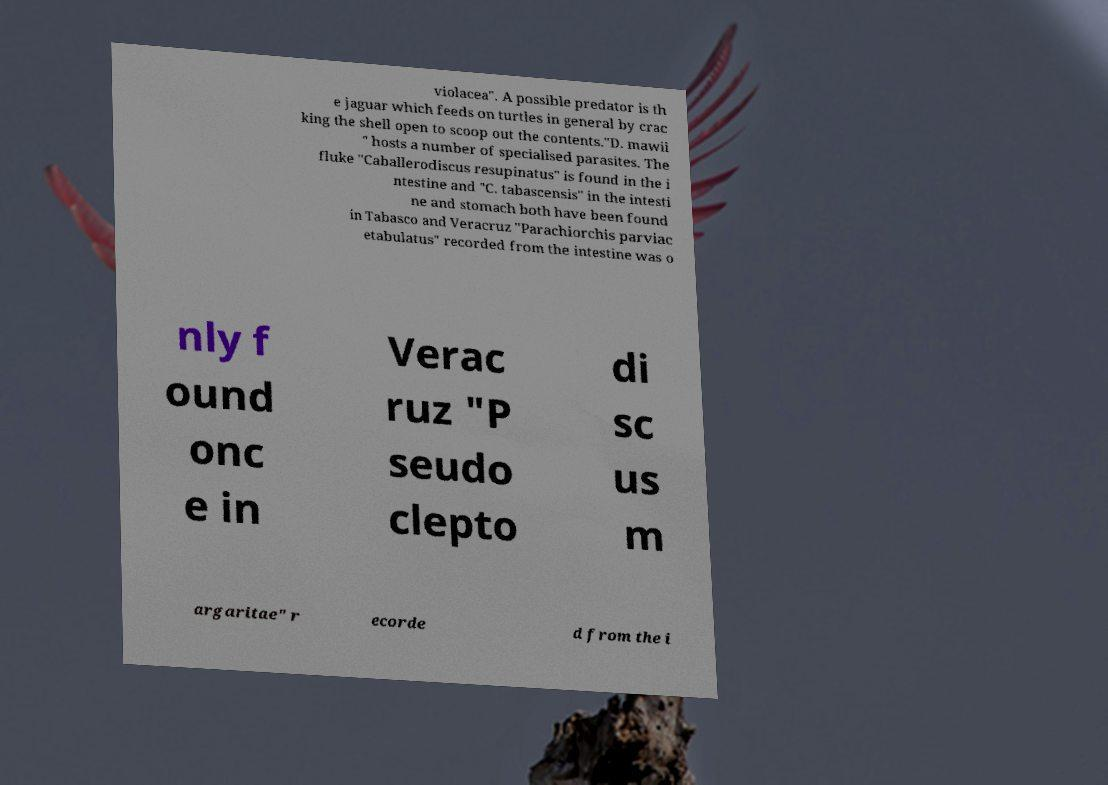For documentation purposes, I need the text within this image transcribed. Could you provide that? violacea". A possible predator is th e jaguar which feeds on turtles in general by crac king the shell open to scoop out the contents."D. mawii " hosts a number of specialised parasites. The fluke "Caballerodiscus resupinatus" is found in the i ntestine and "C. tabascensis" in the intesti ne and stomach both have been found in Tabasco and Veracruz "Parachiorchis parviac etabulatus" recorded from the intestine was o nly f ound onc e in Verac ruz "P seudo clepto di sc us m argaritae" r ecorde d from the i 